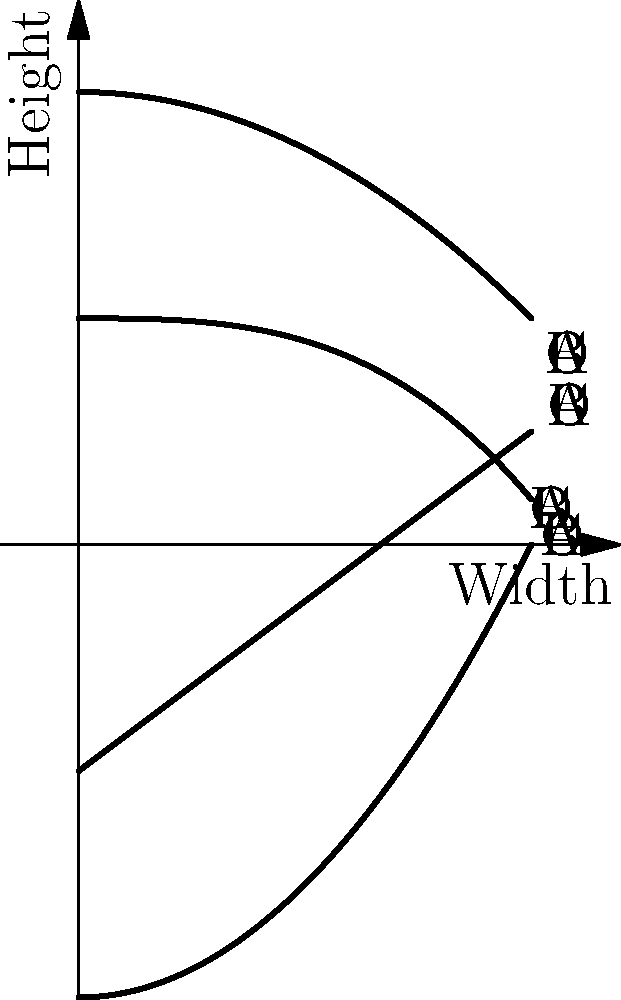In the network diagram above, four different ancient pottery profiles are represented by curves A, B, C, and D. Which curve most likely represents the profile of a classical Greek amphora, known for its distinctive elongated shape with a narrow neck and a pointed base? To identify the profile of a classical Greek amphora, let's analyze each curve:

1. Curve A (solid line): This curve shows a wide base that narrows towards the top. While it has some similarities to an amphora, it lacks the distinctive narrow neck.

2. Curve B (dashed line): This curve represents a shape that is wider at the top and bottom, with a narrower middle. This is not characteristic of an amphora.

3. Curve C (dotted line): This is a straight line with a positive slope, which doesn't represent any typical pottery shape.

4. Curve D (dash-dotted line): This curve shows a shape that starts with a pointed base, widens in the middle, and then narrows again at the top. This profile most closely matches the description of a classical Greek amphora.

The key features of a Greek amphora are:
1. A pointed or narrow base
2. A wide body
3. A narrow neck
4. A slightly flared rim

Curve D exhibits all these characteristics, making it the best match for a classical Greek amphora profile.
Answer: D 